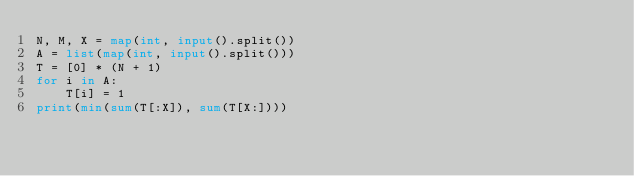<code> <loc_0><loc_0><loc_500><loc_500><_Python_>N, M, X = map(int, input().split())
A = list(map(int, input().split()))
T = [0] * (N + 1)
for i in A:
    T[i] = 1
print(min(sum(T[:X]), sum(T[X:])))
</code> 